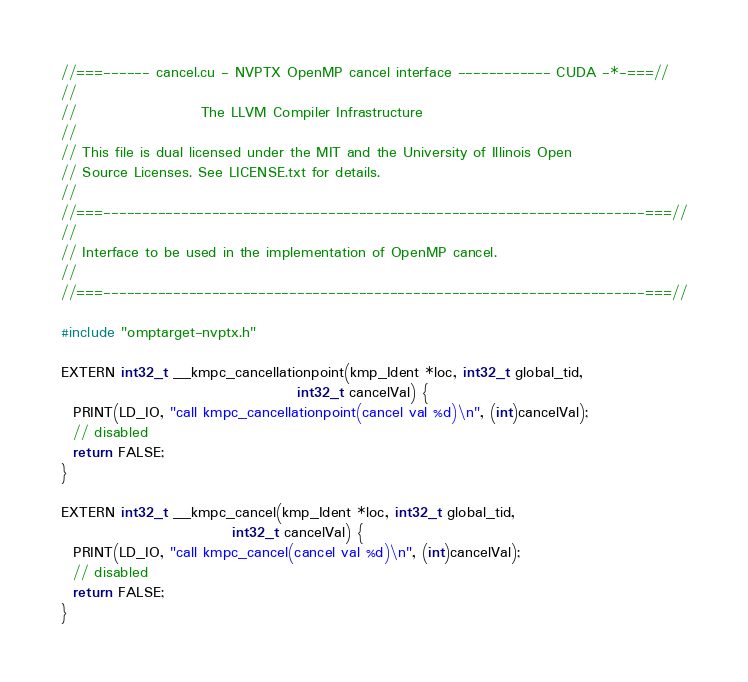Convert code to text. <code><loc_0><loc_0><loc_500><loc_500><_Cuda_>//===------ cancel.cu - NVPTX OpenMP cancel interface ------------ CUDA -*-===//
//
//                     The LLVM Compiler Infrastructure
//
// This file is dual licensed under the MIT and the University of Illinois Open
// Source Licenses. See LICENSE.txt for details.
//
//===----------------------------------------------------------------------===//
//
// Interface to be used in the implementation of OpenMP cancel.
//
//===----------------------------------------------------------------------===//

#include "omptarget-nvptx.h"

EXTERN int32_t __kmpc_cancellationpoint(kmp_Ident *loc, int32_t global_tid,
                                        int32_t cancelVal) {
  PRINT(LD_IO, "call kmpc_cancellationpoint(cancel val %d)\n", (int)cancelVal);
  // disabled
  return FALSE;
}

EXTERN int32_t __kmpc_cancel(kmp_Ident *loc, int32_t global_tid,
                             int32_t cancelVal) {
  PRINT(LD_IO, "call kmpc_cancel(cancel val %d)\n", (int)cancelVal);
  // disabled
  return FALSE;
}
</code> 